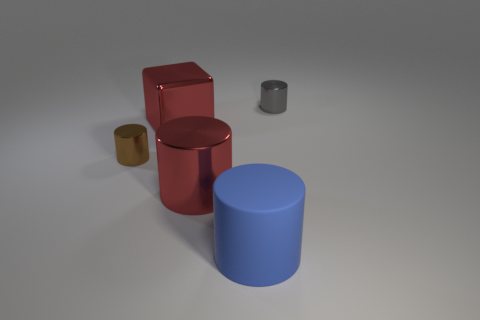Subtract all red cylinders. Subtract all blue cubes. How many cylinders are left? 3 Add 4 brown metal cylinders. How many objects exist? 9 Subtract all blocks. How many objects are left? 4 Add 3 red cylinders. How many red cylinders exist? 4 Subtract 0 yellow blocks. How many objects are left? 5 Subtract all small metal objects. Subtract all big red cylinders. How many objects are left? 2 Add 1 tiny objects. How many tiny objects are left? 3 